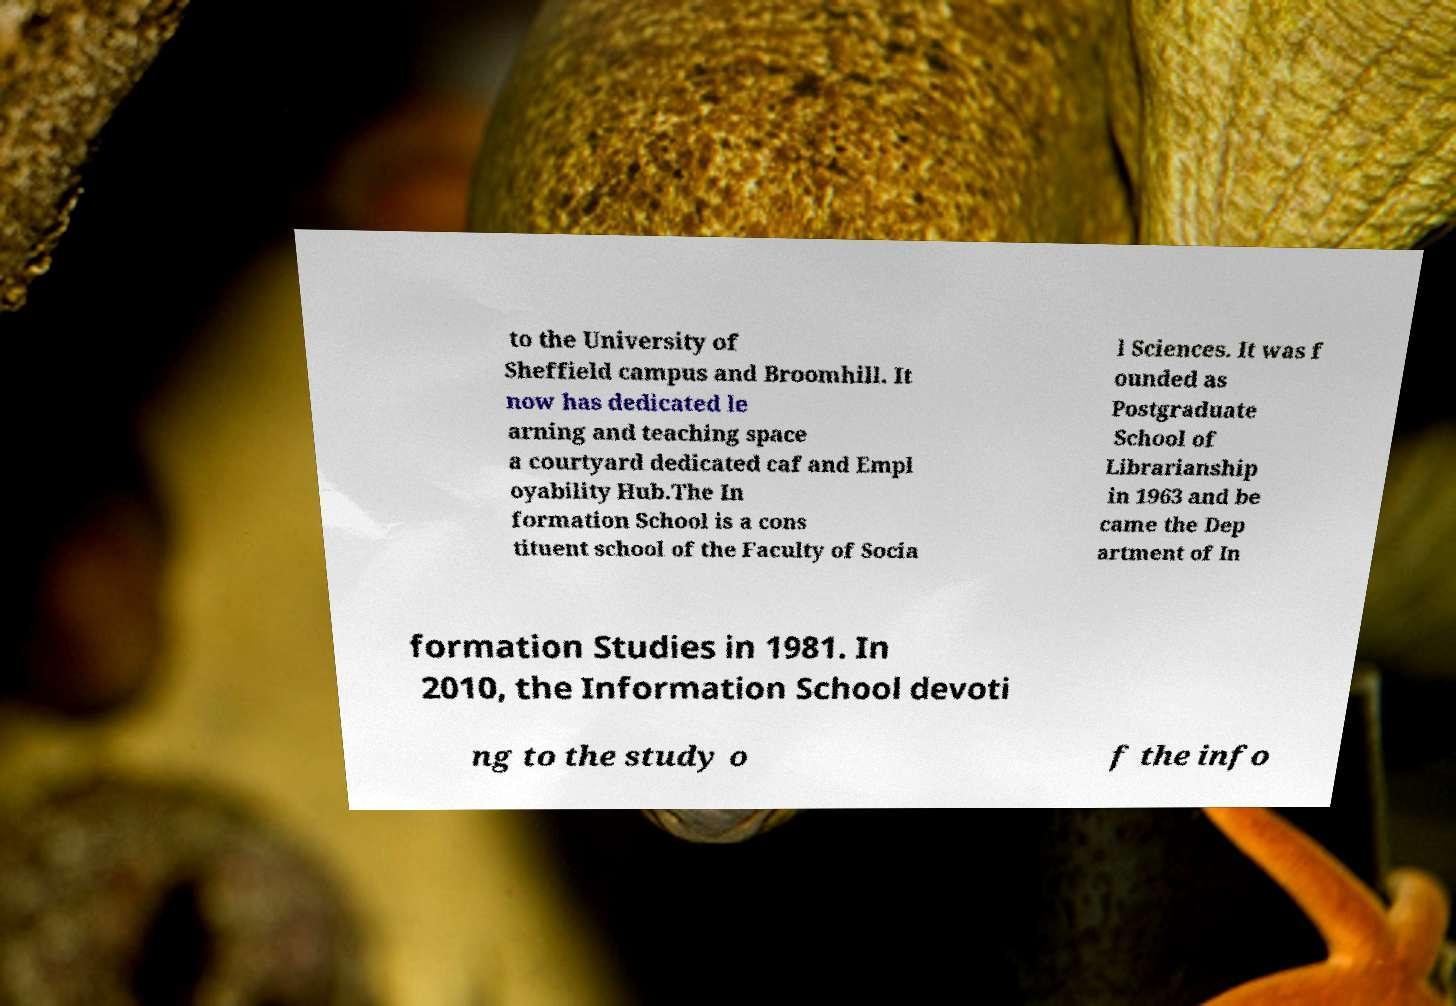Please read and relay the text visible in this image. What does it say? to the University of Sheffield campus and Broomhill. It now has dedicated le arning and teaching space a courtyard dedicated caf and Empl oyability Hub.The In formation School is a cons tituent school of the Faculty of Socia l Sciences. It was f ounded as Postgraduate School of Librarianship in 1963 and be came the Dep artment of In formation Studies in 1981. In 2010, the Information School devoti ng to the study o f the info 